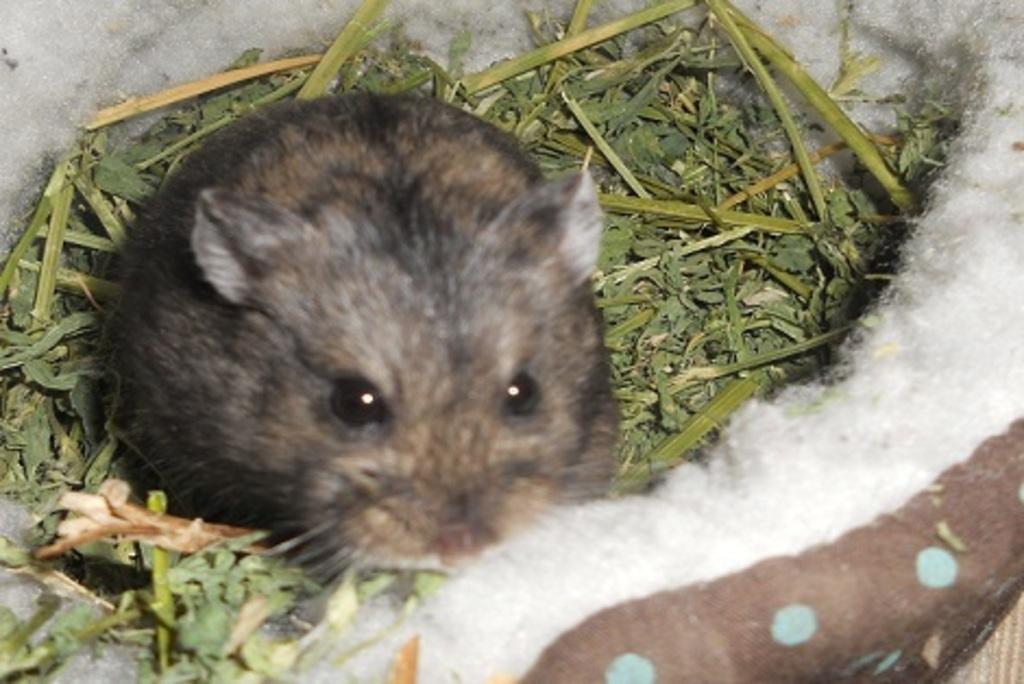What animal is present in the picture? There is a rat in the picture. What type of environment is the rat in? There is grass around the rat. What type of legal advice is the rat providing in the picture? There is no lawyer or legal advice present in the image; it features a rat in grass. 